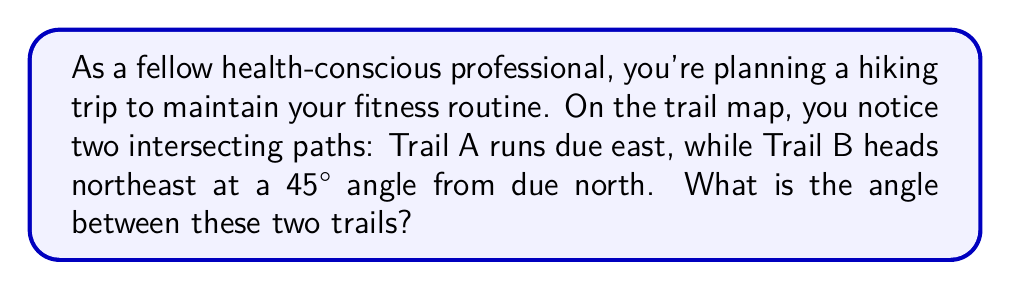What is the answer to this math problem? Let's approach this step-by-step:

1) First, let's visualize the problem:

[asy]
import geometry;

size(200);
draw((0,0)--(100,0),arrow=Arrow(TeXHead));
draw((0,0)--(70.71,70.71),arrow=Arrow(TeXHead));
draw((0,0)--(0,100),dashed);

label("East (Trail A)", (100,0), E);
label("Northeast (Trail B)", (70.71,70.71), NE);
label("North", (0,100), N);

draw(arc((0,0),20,0,45),arrow=Arrow(TeXHead));
label("45°", (15,7), NE);

draw(arc((0,0),30,0,90),arrow=Arrow(TeXHead));
label("θ", (20,20), NW);
[/asy]

2) Trail A runs due east, which is at a 90° angle from north.

3) Trail B runs northeast at a 45° angle from north.

4) To find the angle between the trails, we need to subtract the angle of Trail B from the angle of Trail A:

   $$ \theta = 90° - 45° $$

5) Calculating:

   $$ \theta = 45° $$

Therefore, the angle between the two trails is 45°.
Answer: 45° 